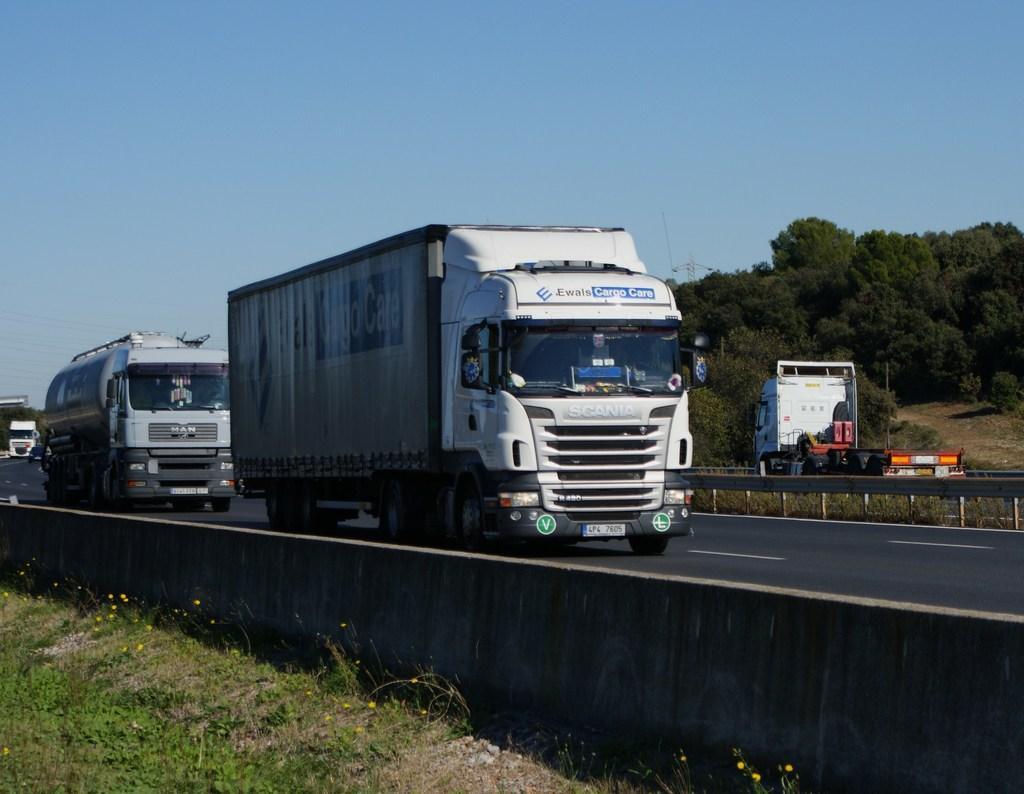Describe this image in one or two sentences. In this image there are grass and sand. There is a wall. We can see the road and vehicles. In the background, I think, there is truck. There are trees. There is sky. 